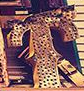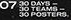What words can you see in these images in sequence, separated by a semicolon? T; # 